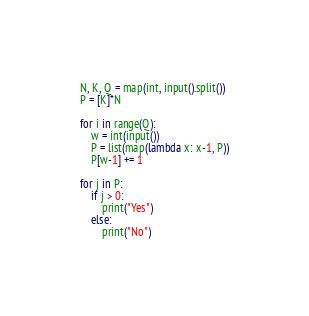<code> <loc_0><loc_0><loc_500><loc_500><_Python_>N, K, Q = map(int, input().split())
P = [K]*N

for i in range(Q):
    w = int(input())
    P = list(map(lambda x: x-1, P))
    P[w-1] += 1

for j in P:
    if j > 0:
        print("Yes")
    else:
        print("No")</code> 